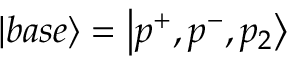Convert formula to latex. <formula><loc_0><loc_0><loc_500><loc_500>\left | b a s e \right \rangle = \left | p ^ { + } , p ^ { - } , p _ { 2 } \right \rangle</formula> 